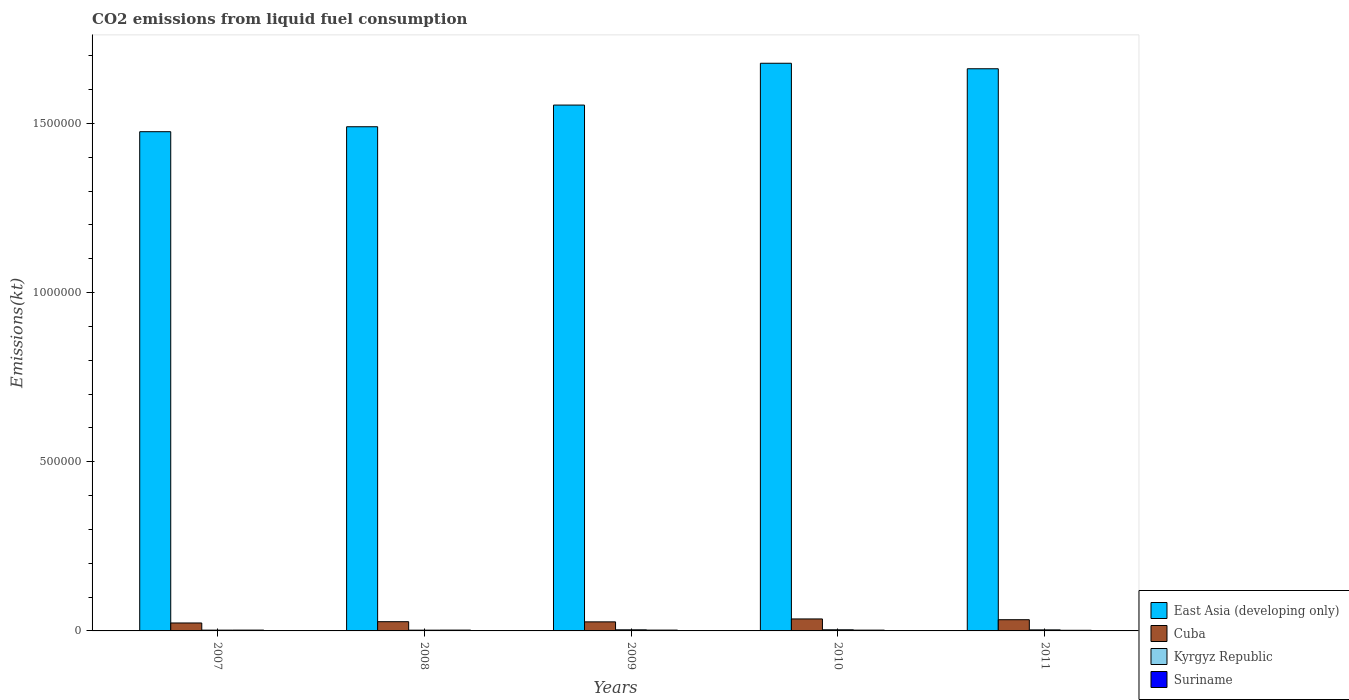How many groups of bars are there?
Offer a terse response. 5. What is the label of the 1st group of bars from the left?
Keep it short and to the point. 2007. In how many cases, is the number of bars for a given year not equal to the number of legend labels?
Keep it short and to the point. 0. What is the amount of CO2 emitted in Cuba in 2011?
Make the answer very short. 3.31e+04. Across all years, what is the maximum amount of CO2 emitted in Suriname?
Your answer should be very brief. 2434.89. Across all years, what is the minimum amount of CO2 emitted in East Asia (developing only)?
Your response must be concise. 1.48e+06. In which year was the amount of CO2 emitted in East Asia (developing only) minimum?
Keep it short and to the point. 2007. What is the total amount of CO2 emitted in Cuba in the graph?
Provide a succinct answer. 1.46e+05. What is the difference between the amount of CO2 emitted in East Asia (developing only) in 2008 and that in 2011?
Your response must be concise. -1.71e+05. What is the difference between the amount of CO2 emitted in Suriname in 2008 and the amount of CO2 emitted in Kyrgyz Republic in 2011?
Your answer should be compact. -689.4. What is the average amount of CO2 emitted in Suriname per year?
Provide a short and direct response. 2295.54. In the year 2008, what is the difference between the amount of CO2 emitted in Suriname and amount of CO2 emitted in Kyrgyz Republic?
Offer a terse response. 187.02. What is the ratio of the amount of CO2 emitted in Kyrgyz Republic in 2007 to that in 2010?
Ensure brevity in your answer.  0.69. What is the difference between the highest and the second highest amount of CO2 emitted in Suriname?
Keep it short and to the point. 25.67. What is the difference between the highest and the lowest amount of CO2 emitted in Cuba?
Ensure brevity in your answer.  1.19e+04. In how many years, is the amount of CO2 emitted in Cuba greater than the average amount of CO2 emitted in Cuba taken over all years?
Your response must be concise. 2. Is the sum of the amount of CO2 emitted in Cuba in 2007 and 2009 greater than the maximum amount of CO2 emitted in East Asia (developing only) across all years?
Your answer should be compact. No. What does the 3rd bar from the left in 2008 represents?
Provide a short and direct response. Kyrgyz Republic. What does the 3rd bar from the right in 2007 represents?
Give a very brief answer. Cuba. What is the difference between two consecutive major ticks on the Y-axis?
Give a very brief answer. 5.00e+05. Does the graph contain any zero values?
Make the answer very short. No. Where does the legend appear in the graph?
Your answer should be compact. Bottom right. How many legend labels are there?
Offer a terse response. 4. How are the legend labels stacked?
Your answer should be compact. Vertical. What is the title of the graph?
Provide a short and direct response. CO2 emissions from liquid fuel consumption. Does "Andorra" appear as one of the legend labels in the graph?
Offer a very short reply. No. What is the label or title of the Y-axis?
Your answer should be very brief. Emissions(kt). What is the Emissions(kt) in East Asia (developing only) in 2007?
Your response must be concise. 1.48e+06. What is the Emissions(kt) in Cuba in 2007?
Your answer should be very brief. 2.35e+04. What is the Emissions(kt) in Kyrgyz Republic in 2007?
Your answer should be compact. 2346.88. What is the Emissions(kt) of Suriname in 2007?
Your response must be concise. 2409.22. What is the Emissions(kt) in East Asia (developing only) in 2008?
Offer a very short reply. 1.49e+06. What is the Emissions(kt) in Cuba in 2008?
Your response must be concise. 2.73e+04. What is the Emissions(kt) of Kyrgyz Republic in 2008?
Give a very brief answer. 2222.2. What is the Emissions(kt) in Suriname in 2008?
Make the answer very short. 2409.22. What is the Emissions(kt) of East Asia (developing only) in 2009?
Your answer should be compact. 1.55e+06. What is the Emissions(kt) in Cuba in 2009?
Your response must be concise. 2.68e+04. What is the Emissions(kt) in Kyrgyz Republic in 2009?
Make the answer very short. 3318.64. What is the Emissions(kt) of Suriname in 2009?
Make the answer very short. 2434.89. What is the Emissions(kt) of East Asia (developing only) in 2010?
Offer a very short reply. 1.68e+06. What is the Emissions(kt) of Cuba in 2010?
Make the answer very short. 3.54e+04. What is the Emissions(kt) in Kyrgyz Republic in 2010?
Your answer should be compact. 3395.64. What is the Emissions(kt) in Suriname in 2010?
Your answer should be very brief. 2350.55. What is the Emissions(kt) in East Asia (developing only) in 2011?
Your answer should be very brief. 1.66e+06. What is the Emissions(kt) in Cuba in 2011?
Ensure brevity in your answer.  3.31e+04. What is the Emissions(kt) of Kyrgyz Republic in 2011?
Offer a very short reply. 3098.61. What is the Emissions(kt) in Suriname in 2011?
Make the answer very short. 1873.84. Across all years, what is the maximum Emissions(kt) of East Asia (developing only)?
Your response must be concise. 1.68e+06. Across all years, what is the maximum Emissions(kt) in Cuba?
Ensure brevity in your answer.  3.54e+04. Across all years, what is the maximum Emissions(kt) in Kyrgyz Republic?
Your answer should be very brief. 3395.64. Across all years, what is the maximum Emissions(kt) in Suriname?
Your answer should be very brief. 2434.89. Across all years, what is the minimum Emissions(kt) in East Asia (developing only)?
Your answer should be compact. 1.48e+06. Across all years, what is the minimum Emissions(kt) of Cuba?
Your answer should be compact. 2.35e+04. Across all years, what is the minimum Emissions(kt) in Kyrgyz Republic?
Provide a short and direct response. 2222.2. Across all years, what is the minimum Emissions(kt) in Suriname?
Your answer should be very brief. 1873.84. What is the total Emissions(kt) in East Asia (developing only) in the graph?
Your answer should be compact. 7.86e+06. What is the total Emissions(kt) in Cuba in the graph?
Provide a succinct answer. 1.46e+05. What is the total Emissions(kt) of Kyrgyz Republic in the graph?
Provide a short and direct response. 1.44e+04. What is the total Emissions(kt) in Suriname in the graph?
Ensure brevity in your answer.  1.15e+04. What is the difference between the Emissions(kt) in East Asia (developing only) in 2007 and that in 2008?
Give a very brief answer. -1.47e+04. What is the difference between the Emissions(kt) of Cuba in 2007 and that in 2008?
Your answer should be compact. -3788.01. What is the difference between the Emissions(kt) of Kyrgyz Republic in 2007 and that in 2008?
Give a very brief answer. 124.68. What is the difference between the Emissions(kt) in Suriname in 2007 and that in 2008?
Your answer should be very brief. 0. What is the difference between the Emissions(kt) of East Asia (developing only) in 2007 and that in 2009?
Give a very brief answer. -7.87e+04. What is the difference between the Emissions(kt) of Cuba in 2007 and that in 2009?
Your answer should be very brief. -3296.63. What is the difference between the Emissions(kt) of Kyrgyz Republic in 2007 and that in 2009?
Provide a succinct answer. -971.75. What is the difference between the Emissions(kt) of Suriname in 2007 and that in 2009?
Offer a very short reply. -25.67. What is the difference between the Emissions(kt) in East Asia (developing only) in 2007 and that in 2010?
Your answer should be compact. -2.02e+05. What is the difference between the Emissions(kt) in Cuba in 2007 and that in 2010?
Your answer should be compact. -1.19e+04. What is the difference between the Emissions(kt) in Kyrgyz Republic in 2007 and that in 2010?
Provide a succinct answer. -1048.76. What is the difference between the Emissions(kt) in Suriname in 2007 and that in 2010?
Ensure brevity in your answer.  58.67. What is the difference between the Emissions(kt) of East Asia (developing only) in 2007 and that in 2011?
Offer a terse response. -1.86e+05. What is the difference between the Emissions(kt) of Cuba in 2007 and that in 2011?
Your answer should be very brief. -9666.21. What is the difference between the Emissions(kt) in Kyrgyz Republic in 2007 and that in 2011?
Offer a terse response. -751.74. What is the difference between the Emissions(kt) of Suriname in 2007 and that in 2011?
Give a very brief answer. 535.38. What is the difference between the Emissions(kt) of East Asia (developing only) in 2008 and that in 2009?
Offer a very short reply. -6.40e+04. What is the difference between the Emissions(kt) of Cuba in 2008 and that in 2009?
Offer a very short reply. 491.38. What is the difference between the Emissions(kt) of Kyrgyz Republic in 2008 and that in 2009?
Make the answer very short. -1096.43. What is the difference between the Emissions(kt) in Suriname in 2008 and that in 2009?
Provide a succinct answer. -25.67. What is the difference between the Emissions(kt) of East Asia (developing only) in 2008 and that in 2010?
Keep it short and to the point. -1.88e+05. What is the difference between the Emissions(kt) of Cuba in 2008 and that in 2010?
Your answer should be compact. -8148.07. What is the difference between the Emissions(kt) in Kyrgyz Republic in 2008 and that in 2010?
Provide a succinct answer. -1173.44. What is the difference between the Emissions(kt) of Suriname in 2008 and that in 2010?
Your answer should be very brief. 58.67. What is the difference between the Emissions(kt) in East Asia (developing only) in 2008 and that in 2011?
Provide a short and direct response. -1.71e+05. What is the difference between the Emissions(kt) in Cuba in 2008 and that in 2011?
Provide a succinct answer. -5878.2. What is the difference between the Emissions(kt) of Kyrgyz Republic in 2008 and that in 2011?
Give a very brief answer. -876.41. What is the difference between the Emissions(kt) in Suriname in 2008 and that in 2011?
Your answer should be very brief. 535.38. What is the difference between the Emissions(kt) in East Asia (developing only) in 2009 and that in 2010?
Make the answer very short. -1.24e+05. What is the difference between the Emissions(kt) in Cuba in 2009 and that in 2010?
Offer a very short reply. -8639.45. What is the difference between the Emissions(kt) in Kyrgyz Republic in 2009 and that in 2010?
Keep it short and to the point. -77.01. What is the difference between the Emissions(kt) of Suriname in 2009 and that in 2010?
Your response must be concise. 84.34. What is the difference between the Emissions(kt) of East Asia (developing only) in 2009 and that in 2011?
Make the answer very short. -1.07e+05. What is the difference between the Emissions(kt) in Cuba in 2009 and that in 2011?
Your answer should be very brief. -6369.58. What is the difference between the Emissions(kt) in Kyrgyz Republic in 2009 and that in 2011?
Keep it short and to the point. 220.02. What is the difference between the Emissions(kt) in Suriname in 2009 and that in 2011?
Your response must be concise. 561.05. What is the difference between the Emissions(kt) of East Asia (developing only) in 2010 and that in 2011?
Offer a terse response. 1.63e+04. What is the difference between the Emissions(kt) of Cuba in 2010 and that in 2011?
Give a very brief answer. 2269.87. What is the difference between the Emissions(kt) in Kyrgyz Republic in 2010 and that in 2011?
Keep it short and to the point. 297.03. What is the difference between the Emissions(kt) of Suriname in 2010 and that in 2011?
Provide a succinct answer. 476.71. What is the difference between the Emissions(kt) of East Asia (developing only) in 2007 and the Emissions(kt) of Cuba in 2008?
Make the answer very short. 1.45e+06. What is the difference between the Emissions(kt) of East Asia (developing only) in 2007 and the Emissions(kt) of Kyrgyz Republic in 2008?
Keep it short and to the point. 1.47e+06. What is the difference between the Emissions(kt) of East Asia (developing only) in 2007 and the Emissions(kt) of Suriname in 2008?
Offer a terse response. 1.47e+06. What is the difference between the Emissions(kt) in Cuba in 2007 and the Emissions(kt) in Kyrgyz Republic in 2008?
Make the answer very short. 2.13e+04. What is the difference between the Emissions(kt) in Cuba in 2007 and the Emissions(kt) in Suriname in 2008?
Ensure brevity in your answer.  2.11e+04. What is the difference between the Emissions(kt) of Kyrgyz Republic in 2007 and the Emissions(kt) of Suriname in 2008?
Offer a very short reply. -62.34. What is the difference between the Emissions(kt) in East Asia (developing only) in 2007 and the Emissions(kt) in Cuba in 2009?
Provide a succinct answer. 1.45e+06. What is the difference between the Emissions(kt) in East Asia (developing only) in 2007 and the Emissions(kt) in Kyrgyz Republic in 2009?
Give a very brief answer. 1.47e+06. What is the difference between the Emissions(kt) of East Asia (developing only) in 2007 and the Emissions(kt) of Suriname in 2009?
Keep it short and to the point. 1.47e+06. What is the difference between the Emissions(kt) in Cuba in 2007 and the Emissions(kt) in Kyrgyz Republic in 2009?
Offer a terse response. 2.02e+04. What is the difference between the Emissions(kt) of Cuba in 2007 and the Emissions(kt) of Suriname in 2009?
Your answer should be compact. 2.10e+04. What is the difference between the Emissions(kt) of Kyrgyz Republic in 2007 and the Emissions(kt) of Suriname in 2009?
Provide a short and direct response. -88.01. What is the difference between the Emissions(kt) in East Asia (developing only) in 2007 and the Emissions(kt) in Cuba in 2010?
Provide a short and direct response. 1.44e+06. What is the difference between the Emissions(kt) of East Asia (developing only) in 2007 and the Emissions(kt) of Kyrgyz Republic in 2010?
Give a very brief answer. 1.47e+06. What is the difference between the Emissions(kt) of East Asia (developing only) in 2007 and the Emissions(kt) of Suriname in 2010?
Provide a short and direct response. 1.47e+06. What is the difference between the Emissions(kt) of Cuba in 2007 and the Emissions(kt) of Kyrgyz Republic in 2010?
Keep it short and to the point. 2.01e+04. What is the difference between the Emissions(kt) in Cuba in 2007 and the Emissions(kt) in Suriname in 2010?
Your response must be concise. 2.11e+04. What is the difference between the Emissions(kt) in Kyrgyz Republic in 2007 and the Emissions(kt) in Suriname in 2010?
Make the answer very short. -3.67. What is the difference between the Emissions(kt) of East Asia (developing only) in 2007 and the Emissions(kt) of Cuba in 2011?
Make the answer very short. 1.44e+06. What is the difference between the Emissions(kt) of East Asia (developing only) in 2007 and the Emissions(kt) of Kyrgyz Republic in 2011?
Keep it short and to the point. 1.47e+06. What is the difference between the Emissions(kt) in East Asia (developing only) in 2007 and the Emissions(kt) in Suriname in 2011?
Keep it short and to the point. 1.47e+06. What is the difference between the Emissions(kt) of Cuba in 2007 and the Emissions(kt) of Kyrgyz Republic in 2011?
Give a very brief answer. 2.04e+04. What is the difference between the Emissions(kt) in Cuba in 2007 and the Emissions(kt) in Suriname in 2011?
Your response must be concise. 2.16e+04. What is the difference between the Emissions(kt) in Kyrgyz Republic in 2007 and the Emissions(kt) in Suriname in 2011?
Your response must be concise. 473.04. What is the difference between the Emissions(kt) of East Asia (developing only) in 2008 and the Emissions(kt) of Cuba in 2009?
Keep it short and to the point. 1.46e+06. What is the difference between the Emissions(kt) in East Asia (developing only) in 2008 and the Emissions(kt) in Kyrgyz Republic in 2009?
Your answer should be very brief. 1.49e+06. What is the difference between the Emissions(kt) in East Asia (developing only) in 2008 and the Emissions(kt) in Suriname in 2009?
Your answer should be very brief. 1.49e+06. What is the difference between the Emissions(kt) in Cuba in 2008 and the Emissions(kt) in Kyrgyz Republic in 2009?
Make the answer very short. 2.40e+04. What is the difference between the Emissions(kt) of Cuba in 2008 and the Emissions(kt) of Suriname in 2009?
Provide a succinct answer. 2.48e+04. What is the difference between the Emissions(kt) in Kyrgyz Republic in 2008 and the Emissions(kt) in Suriname in 2009?
Your answer should be very brief. -212.69. What is the difference between the Emissions(kt) in East Asia (developing only) in 2008 and the Emissions(kt) in Cuba in 2010?
Ensure brevity in your answer.  1.45e+06. What is the difference between the Emissions(kt) in East Asia (developing only) in 2008 and the Emissions(kt) in Kyrgyz Republic in 2010?
Offer a terse response. 1.49e+06. What is the difference between the Emissions(kt) of East Asia (developing only) in 2008 and the Emissions(kt) of Suriname in 2010?
Provide a short and direct response. 1.49e+06. What is the difference between the Emissions(kt) of Cuba in 2008 and the Emissions(kt) of Kyrgyz Republic in 2010?
Ensure brevity in your answer.  2.39e+04. What is the difference between the Emissions(kt) of Cuba in 2008 and the Emissions(kt) of Suriname in 2010?
Keep it short and to the point. 2.49e+04. What is the difference between the Emissions(kt) in Kyrgyz Republic in 2008 and the Emissions(kt) in Suriname in 2010?
Provide a short and direct response. -128.34. What is the difference between the Emissions(kt) of East Asia (developing only) in 2008 and the Emissions(kt) of Cuba in 2011?
Give a very brief answer. 1.46e+06. What is the difference between the Emissions(kt) in East Asia (developing only) in 2008 and the Emissions(kt) in Kyrgyz Republic in 2011?
Offer a terse response. 1.49e+06. What is the difference between the Emissions(kt) of East Asia (developing only) in 2008 and the Emissions(kt) of Suriname in 2011?
Your response must be concise. 1.49e+06. What is the difference between the Emissions(kt) of Cuba in 2008 and the Emissions(kt) of Kyrgyz Republic in 2011?
Your answer should be compact. 2.42e+04. What is the difference between the Emissions(kt) in Cuba in 2008 and the Emissions(kt) in Suriname in 2011?
Provide a succinct answer. 2.54e+04. What is the difference between the Emissions(kt) of Kyrgyz Republic in 2008 and the Emissions(kt) of Suriname in 2011?
Provide a short and direct response. 348.37. What is the difference between the Emissions(kt) in East Asia (developing only) in 2009 and the Emissions(kt) in Cuba in 2010?
Offer a very short reply. 1.52e+06. What is the difference between the Emissions(kt) in East Asia (developing only) in 2009 and the Emissions(kt) in Kyrgyz Republic in 2010?
Your response must be concise. 1.55e+06. What is the difference between the Emissions(kt) in East Asia (developing only) in 2009 and the Emissions(kt) in Suriname in 2010?
Your answer should be very brief. 1.55e+06. What is the difference between the Emissions(kt) in Cuba in 2009 and the Emissions(kt) in Kyrgyz Republic in 2010?
Offer a very short reply. 2.34e+04. What is the difference between the Emissions(kt) of Cuba in 2009 and the Emissions(kt) of Suriname in 2010?
Provide a short and direct response. 2.44e+04. What is the difference between the Emissions(kt) of Kyrgyz Republic in 2009 and the Emissions(kt) of Suriname in 2010?
Offer a terse response. 968.09. What is the difference between the Emissions(kt) of East Asia (developing only) in 2009 and the Emissions(kt) of Cuba in 2011?
Offer a very short reply. 1.52e+06. What is the difference between the Emissions(kt) of East Asia (developing only) in 2009 and the Emissions(kt) of Kyrgyz Republic in 2011?
Give a very brief answer. 1.55e+06. What is the difference between the Emissions(kt) in East Asia (developing only) in 2009 and the Emissions(kt) in Suriname in 2011?
Your response must be concise. 1.55e+06. What is the difference between the Emissions(kt) in Cuba in 2009 and the Emissions(kt) in Kyrgyz Republic in 2011?
Keep it short and to the point. 2.37e+04. What is the difference between the Emissions(kt) in Cuba in 2009 and the Emissions(kt) in Suriname in 2011?
Give a very brief answer. 2.49e+04. What is the difference between the Emissions(kt) in Kyrgyz Republic in 2009 and the Emissions(kt) in Suriname in 2011?
Your answer should be compact. 1444.8. What is the difference between the Emissions(kt) of East Asia (developing only) in 2010 and the Emissions(kt) of Cuba in 2011?
Ensure brevity in your answer.  1.64e+06. What is the difference between the Emissions(kt) in East Asia (developing only) in 2010 and the Emissions(kt) in Kyrgyz Republic in 2011?
Give a very brief answer. 1.67e+06. What is the difference between the Emissions(kt) of East Asia (developing only) in 2010 and the Emissions(kt) of Suriname in 2011?
Offer a terse response. 1.68e+06. What is the difference between the Emissions(kt) of Cuba in 2010 and the Emissions(kt) of Kyrgyz Republic in 2011?
Ensure brevity in your answer.  3.23e+04. What is the difference between the Emissions(kt) of Cuba in 2010 and the Emissions(kt) of Suriname in 2011?
Ensure brevity in your answer.  3.35e+04. What is the difference between the Emissions(kt) in Kyrgyz Republic in 2010 and the Emissions(kt) in Suriname in 2011?
Your answer should be compact. 1521.81. What is the average Emissions(kt) in East Asia (developing only) per year?
Offer a very short reply. 1.57e+06. What is the average Emissions(kt) of Cuba per year?
Provide a short and direct response. 2.92e+04. What is the average Emissions(kt) in Kyrgyz Republic per year?
Your answer should be very brief. 2876.39. What is the average Emissions(kt) of Suriname per year?
Provide a succinct answer. 2295.54. In the year 2007, what is the difference between the Emissions(kt) in East Asia (developing only) and Emissions(kt) in Cuba?
Offer a very short reply. 1.45e+06. In the year 2007, what is the difference between the Emissions(kt) in East Asia (developing only) and Emissions(kt) in Kyrgyz Republic?
Offer a terse response. 1.47e+06. In the year 2007, what is the difference between the Emissions(kt) of East Asia (developing only) and Emissions(kt) of Suriname?
Offer a terse response. 1.47e+06. In the year 2007, what is the difference between the Emissions(kt) of Cuba and Emissions(kt) of Kyrgyz Republic?
Provide a succinct answer. 2.11e+04. In the year 2007, what is the difference between the Emissions(kt) in Cuba and Emissions(kt) in Suriname?
Offer a terse response. 2.11e+04. In the year 2007, what is the difference between the Emissions(kt) in Kyrgyz Republic and Emissions(kt) in Suriname?
Keep it short and to the point. -62.34. In the year 2008, what is the difference between the Emissions(kt) of East Asia (developing only) and Emissions(kt) of Cuba?
Ensure brevity in your answer.  1.46e+06. In the year 2008, what is the difference between the Emissions(kt) of East Asia (developing only) and Emissions(kt) of Kyrgyz Republic?
Ensure brevity in your answer.  1.49e+06. In the year 2008, what is the difference between the Emissions(kt) of East Asia (developing only) and Emissions(kt) of Suriname?
Provide a succinct answer. 1.49e+06. In the year 2008, what is the difference between the Emissions(kt) of Cuba and Emissions(kt) of Kyrgyz Republic?
Offer a very short reply. 2.50e+04. In the year 2008, what is the difference between the Emissions(kt) of Cuba and Emissions(kt) of Suriname?
Offer a very short reply. 2.49e+04. In the year 2008, what is the difference between the Emissions(kt) in Kyrgyz Republic and Emissions(kt) in Suriname?
Provide a short and direct response. -187.02. In the year 2009, what is the difference between the Emissions(kt) of East Asia (developing only) and Emissions(kt) of Cuba?
Make the answer very short. 1.53e+06. In the year 2009, what is the difference between the Emissions(kt) of East Asia (developing only) and Emissions(kt) of Kyrgyz Republic?
Keep it short and to the point. 1.55e+06. In the year 2009, what is the difference between the Emissions(kt) in East Asia (developing only) and Emissions(kt) in Suriname?
Ensure brevity in your answer.  1.55e+06. In the year 2009, what is the difference between the Emissions(kt) in Cuba and Emissions(kt) in Kyrgyz Republic?
Offer a very short reply. 2.35e+04. In the year 2009, what is the difference between the Emissions(kt) in Cuba and Emissions(kt) in Suriname?
Your answer should be very brief. 2.43e+04. In the year 2009, what is the difference between the Emissions(kt) of Kyrgyz Republic and Emissions(kt) of Suriname?
Give a very brief answer. 883.75. In the year 2010, what is the difference between the Emissions(kt) of East Asia (developing only) and Emissions(kt) of Cuba?
Your answer should be very brief. 1.64e+06. In the year 2010, what is the difference between the Emissions(kt) of East Asia (developing only) and Emissions(kt) of Kyrgyz Republic?
Your answer should be very brief. 1.67e+06. In the year 2010, what is the difference between the Emissions(kt) in East Asia (developing only) and Emissions(kt) in Suriname?
Offer a terse response. 1.68e+06. In the year 2010, what is the difference between the Emissions(kt) in Cuba and Emissions(kt) in Kyrgyz Republic?
Offer a terse response. 3.20e+04. In the year 2010, what is the difference between the Emissions(kt) of Cuba and Emissions(kt) of Suriname?
Ensure brevity in your answer.  3.31e+04. In the year 2010, what is the difference between the Emissions(kt) of Kyrgyz Republic and Emissions(kt) of Suriname?
Provide a succinct answer. 1045.1. In the year 2011, what is the difference between the Emissions(kt) of East Asia (developing only) and Emissions(kt) of Cuba?
Your answer should be very brief. 1.63e+06. In the year 2011, what is the difference between the Emissions(kt) in East Asia (developing only) and Emissions(kt) in Kyrgyz Republic?
Keep it short and to the point. 1.66e+06. In the year 2011, what is the difference between the Emissions(kt) of East Asia (developing only) and Emissions(kt) of Suriname?
Offer a terse response. 1.66e+06. In the year 2011, what is the difference between the Emissions(kt) in Cuba and Emissions(kt) in Kyrgyz Republic?
Ensure brevity in your answer.  3.01e+04. In the year 2011, what is the difference between the Emissions(kt) in Cuba and Emissions(kt) in Suriname?
Your answer should be compact. 3.13e+04. In the year 2011, what is the difference between the Emissions(kt) of Kyrgyz Republic and Emissions(kt) of Suriname?
Your answer should be very brief. 1224.78. What is the ratio of the Emissions(kt) in East Asia (developing only) in 2007 to that in 2008?
Offer a very short reply. 0.99. What is the ratio of the Emissions(kt) in Cuba in 2007 to that in 2008?
Offer a very short reply. 0.86. What is the ratio of the Emissions(kt) in Kyrgyz Republic in 2007 to that in 2008?
Your answer should be compact. 1.06. What is the ratio of the Emissions(kt) in Suriname in 2007 to that in 2008?
Make the answer very short. 1. What is the ratio of the Emissions(kt) of East Asia (developing only) in 2007 to that in 2009?
Your answer should be very brief. 0.95. What is the ratio of the Emissions(kt) of Cuba in 2007 to that in 2009?
Offer a very short reply. 0.88. What is the ratio of the Emissions(kt) in Kyrgyz Republic in 2007 to that in 2009?
Ensure brevity in your answer.  0.71. What is the ratio of the Emissions(kt) in Suriname in 2007 to that in 2009?
Offer a terse response. 0.99. What is the ratio of the Emissions(kt) in East Asia (developing only) in 2007 to that in 2010?
Offer a terse response. 0.88. What is the ratio of the Emissions(kt) in Cuba in 2007 to that in 2010?
Give a very brief answer. 0.66. What is the ratio of the Emissions(kt) in Kyrgyz Republic in 2007 to that in 2010?
Make the answer very short. 0.69. What is the ratio of the Emissions(kt) of East Asia (developing only) in 2007 to that in 2011?
Offer a terse response. 0.89. What is the ratio of the Emissions(kt) in Cuba in 2007 to that in 2011?
Offer a very short reply. 0.71. What is the ratio of the Emissions(kt) of Kyrgyz Republic in 2007 to that in 2011?
Provide a succinct answer. 0.76. What is the ratio of the Emissions(kt) of East Asia (developing only) in 2008 to that in 2009?
Keep it short and to the point. 0.96. What is the ratio of the Emissions(kt) of Cuba in 2008 to that in 2009?
Make the answer very short. 1.02. What is the ratio of the Emissions(kt) in Kyrgyz Republic in 2008 to that in 2009?
Give a very brief answer. 0.67. What is the ratio of the Emissions(kt) of East Asia (developing only) in 2008 to that in 2010?
Your answer should be very brief. 0.89. What is the ratio of the Emissions(kt) of Cuba in 2008 to that in 2010?
Provide a short and direct response. 0.77. What is the ratio of the Emissions(kt) in Kyrgyz Republic in 2008 to that in 2010?
Offer a terse response. 0.65. What is the ratio of the Emissions(kt) in Suriname in 2008 to that in 2010?
Your answer should be very brief. 1.02. What is the ratio of the Emissions(kt) in East Asia (developing only) in 2008 to that in 2011?
Provide a succinct answer. 0.9. What is the ratio of the Emissions(kt) in Cuba in 2008 to that in 2011?
Your answer should be very brief. 0.82. What is the ratio of the Emissions(kt) of Kyrgyz Republic in 2008 to that in 2011?
Your answer should be very brief. 0.72. What is the ratio of the Emissions(kt) in Suriname in 2008 to that in 2011?
Offer a terse response. 1.29. What is the ratio of the Emissions(kt) in East Asia (developing only) in 2009 to that in 2010?
Offer a very short reply. 0.93. What is the ratio of the Emissions(kt) of Cuba in 2009 to that in 2010?
Your answer should be very brief. 0.76. What is the ratio of the Emissions(kt) in Kyrgyz Republic in 2009 to that in 2010?
Give a very brief answer. 0.98. What is the ratio of the Emissions(kt) of Suriname in 2009 to that in 2010?
Keep it short and to the point. 1.04. What is the ratio of the Emissions(kt) in East Asia (developing only) in 2009 to that in 2011?
Keep it short and to the point. 0.94. What is the ratio of the Emissions(kt) of Cuba in 2009 to that in 2011?
Your answer should be very brief. 0.81. What is the ratio of the Emissions(kt) of Kyrgyz Republic in 2009 to that in 2011?
Provide a short and direct response. 1.07. What is the ratio of the Emissions(kt) of Suriname in 2009 to that in 2011?
Keep it short and to the point. 1.3. What is the ratio of the Emissions(kt) of East Asia (developing only) in 2010 to that in 2011?
Offer a very short reply. 1.01. What is the ratio of the Emissions(kt) of Cuba in 2010 to that in 2011?
Ensure brevity in your answer.  1.07. What is the ratio of the Emissions(kt) of Kyrgyz Republic in 2010 to that in 2011?
Your response must be concise. 1.1. What is the ratio of the Emissions(kt) in Suriname in 2010 to that in 2011?
Make the answer very short. 1.25. What is the difference between the highest and the second highest Emissions(kt) of East Asia (developing only)?
Make the answer very short. 1.63e+04. What is the difference between the highest and the second highest Emissions(kt) of Cuba?
Your answer should be compact. 2269.87. What is the difference between the highest and the second highest Emissions(kt) in Kyrgyz Republic?
Keep it short and to the point. 77.01. What is the difference between the highest and the second highest Emissions(kt) of Suriname?
Offer a terse response. 25.67. What is the difference between the highest and the lowest Emissions(kt) of East Asia (developing only)?
Make the answer very short. 2.02e+05. What is the difference between the highest and the lowest Emissions(kt) in Cuba?
Your response must be concise. 1.19e+04. What is the difference between the highest and the lowest Emissions(kt) of Kyrgyz Republic?
Offer a very short reply. 1173.44. What is the difference between the highest and the lowest Emissions(kt) of Suriname?
Provide a succinct answer. 561.05. 